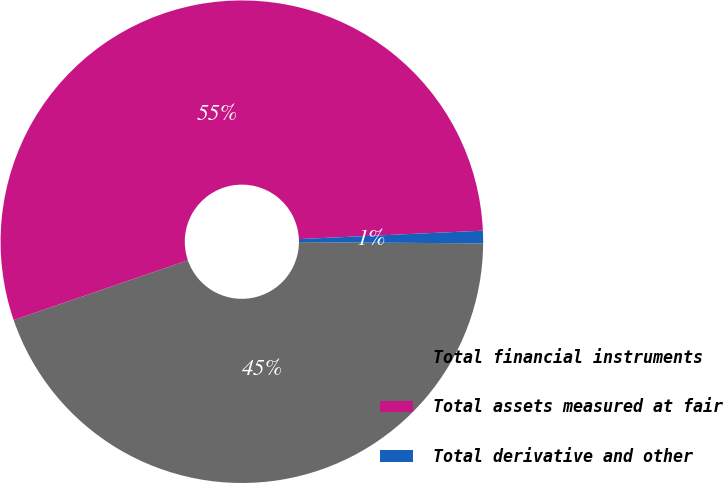Convert chart to OTSL. <chart><loc_0><loc_0><loc_500><loc_500><pie_chart><fcel>Total financial instruments<fcel>Total assets measured at fair<fcel>Total derivative and other<nl><fcel>44.63%<fcel>54.54%<fcel>0.84%<nl></chart> 